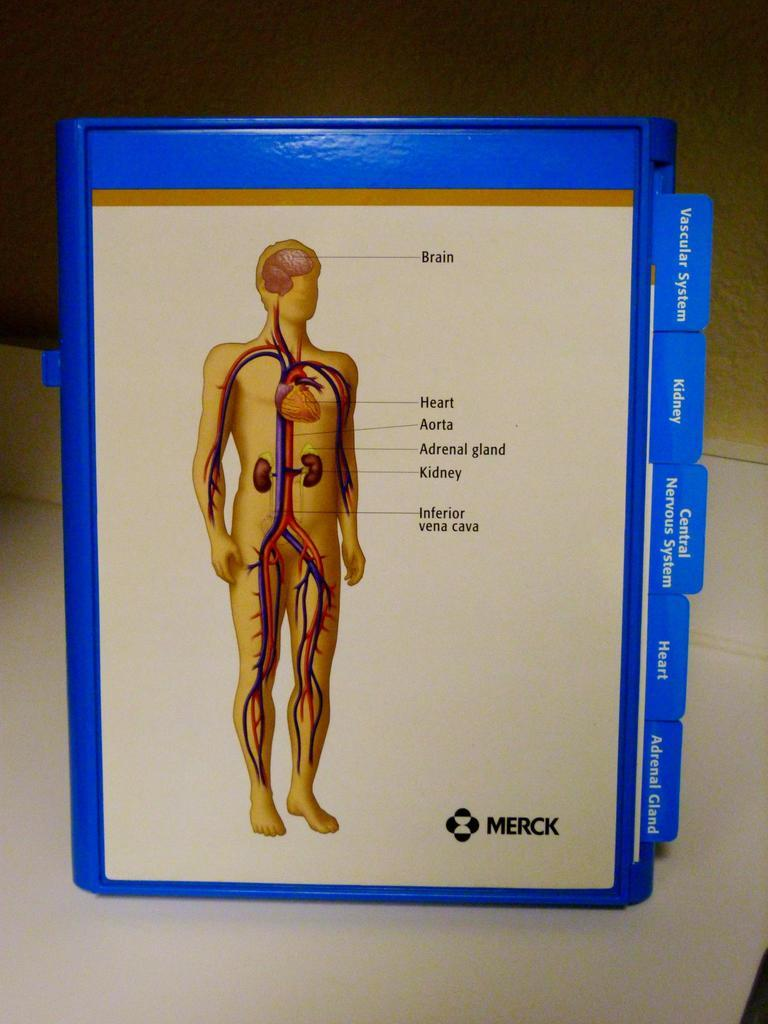What is the main object in the image? There is a book with text and an image in the image. Where is the book located? The book is on a table. What can be seen in the background of the image? There is a wall in the background of the image. What type of nut is used as a reward for the guide in the image? There is no nut, reward, or guide present in the image. 